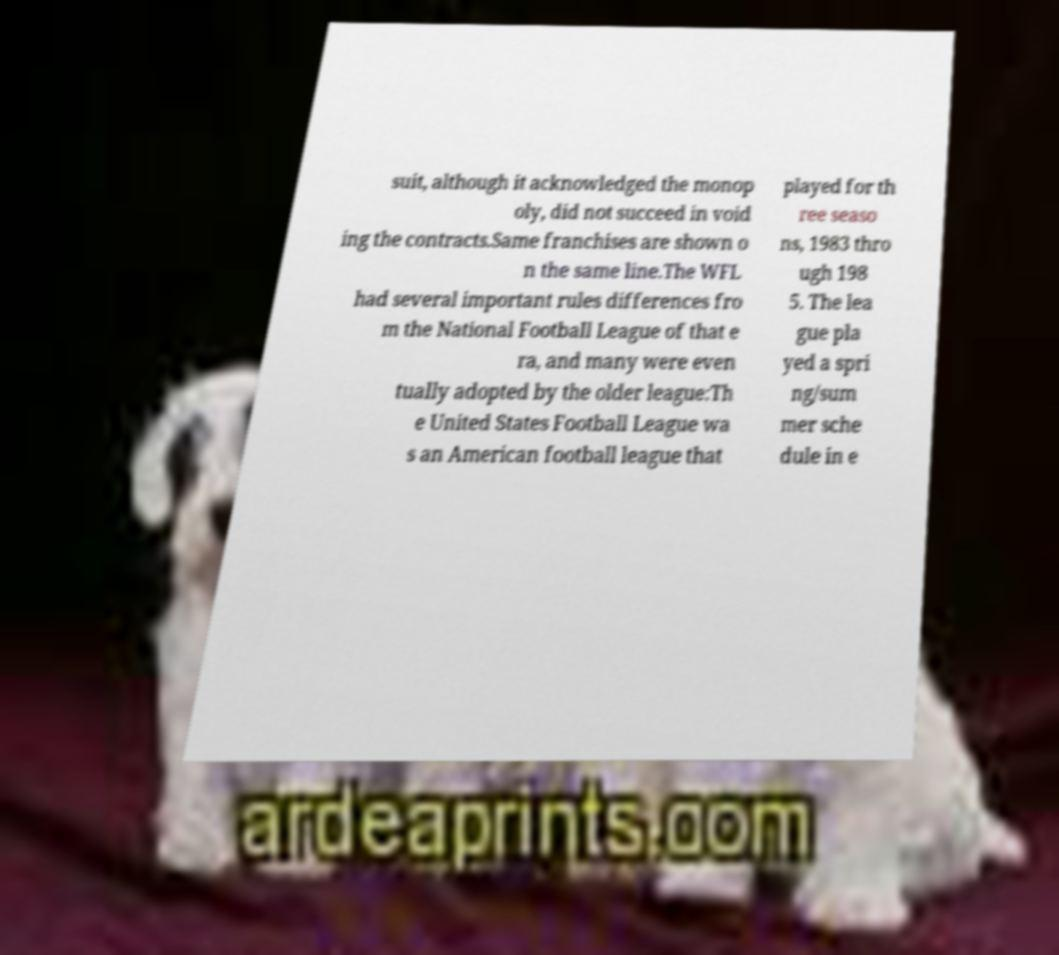For documentation purposes, I need the text within this image transcribed. Could you provide that? suit, although it acknowledged the monop oly, did not succeed in void ing the contracts.Same franchises are shown o n the same line.The WFL had several important rules differences fro m the National Football League of that e ra, and many were even tually adopted by the older league:Th e United States Football League wa s an American football league that played for th ree seaso ns, 1983 thro ugh 198 5. The lea gue pla yed a spri ng/sum mer sche dule in e 